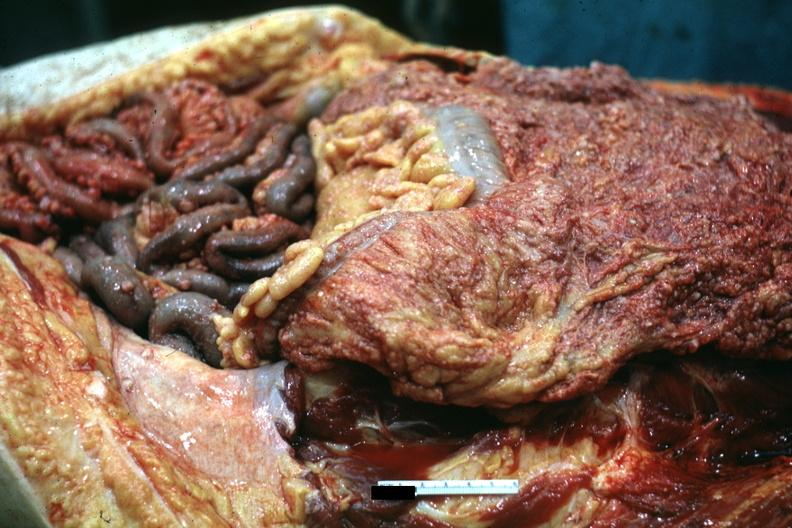s pus in test tube present?
Answer the question using a single word or phrase. No 